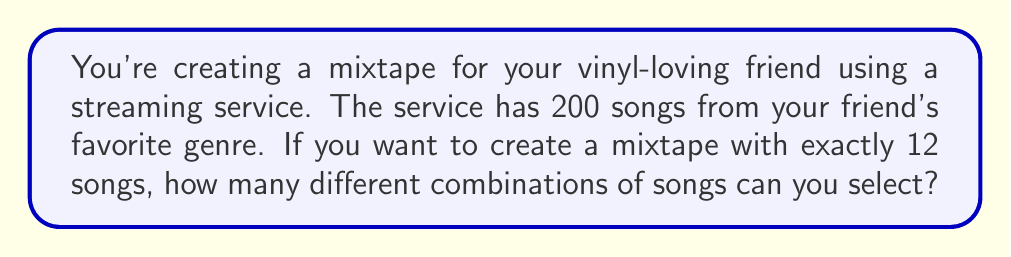Solve this math problem. Let's approach this step-by-step:

1) This is a combination problem. We're selecting 12 songs from a pool of 200, where the order doesn't matter (it's a mixtape, not a playlist).

2) The formula for combinations is:

   $$C(n,r) = \frac{n!}{r!(n-r)!}$$

   where $n$ is the total number of items to choose from, and $r$ is the number of items being chosen.

3) In this case, $n = 200$ (total songs) and $r = 12$ (songs on the mixtape).

4) Plugging these values into our formula:

   $$C(200,12) = \frac{200!}{12!(200-12)!} = \frac{200!}{12!188!}$$

5) This can be calculated as:

   $$\frac{200 \cdot 199 \cdot 198 \cdot 197 \cdot 196 \cdot 195 \cdot 194 \cdot 193 \cdot 192 \cdot 191 \cdot 190 \cdot 189}{12 \cdot 11 \cdot 10 \cdot 9 \cdot 8 \cdot 7 \cdot 6 \cdot 5 \cdot 4 \cdot 3 \cdot 2 \cdot 1}$$

6) Using a calculator (as this is a large number), we get:

   $$C(200,12) = 2,245,940,534,850,400$$

Therefore, there are 2,245,940,534,850,400 different possible combinations of 12 songs that can be selected from 200 songs for the mixtape.
Answer: 2,245,940,534,850,400 